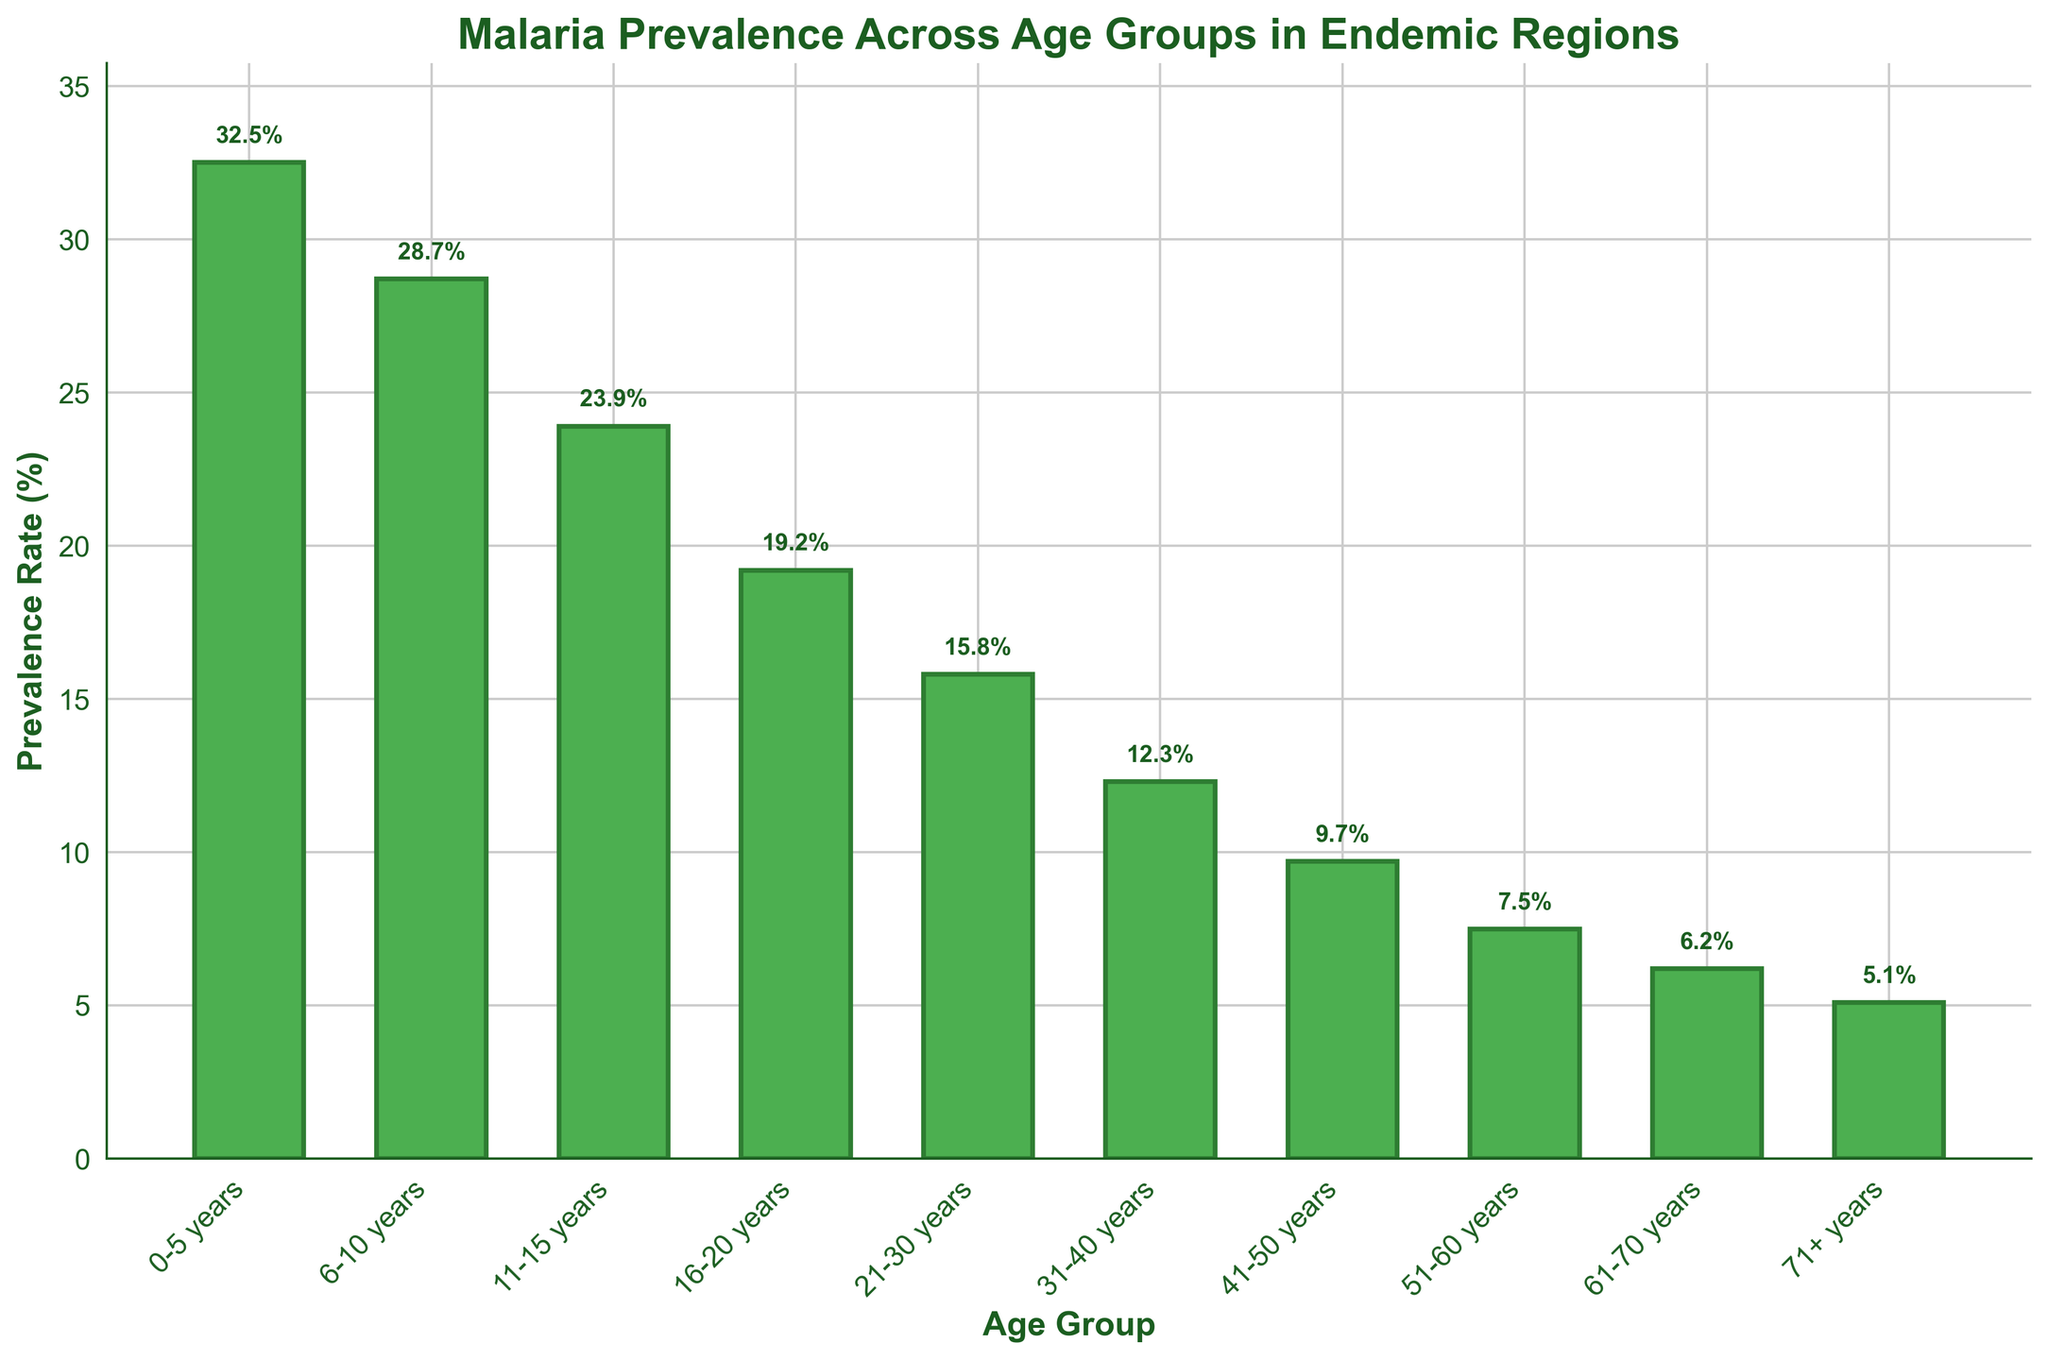What age group has the highest malaria prevalence rate? The figure shows the highest bar corresponding to the age group 0-5 years with a prevalence rate of 32.5%.
Answer: 0-5 years What age group has the lowest malaria prevalence rate? The figure shows the shortest bar corresponding to the age group 71+ years with a prevalence rate of 5.1%.
Answer: 71+ years What is the difference in malaria prevalence between the age groups 0-5 years and 51-60 years? The figure shows the prevalence for 0-5 years as 32.5% and for 51-60 years as 7.5%. Therefore, the difference is 32.5% - 7.5%.
Answer: 25% How does the prevalence rate change as age increases from 0-5 years to 71+ years? By observing the heights of the bars, it can be seen that the prevalence rate decreases as the age group increases from 0-5 years to 71+ years.
Answer: Decreases Which age group has a prevalence rate closest to 20%? The figure shows that the prevalence rate for the age group 16-20 years is 19.2%, which is closest to 20%.
Answer: 16-20 years What is the sum of the prevalence rates for the age groups 21-30 years and 31-40 years? The prevalence rates for the age groups 21-30 years and 31-40 years are 15.8% and 12.3%, respectively. Adding these values together gives 15.8% + 12.3%.
Answer: 28.1% Is the prevalence rate for the age group 41-50 years greater or less than 10%? The figure shows the prevalence rate for the age group 41-50 years as 9.7%, which is less than 10%.
Answer: Less What is the average prevalence rate of malaria for all age groups under 20 years? The prevalence rates for the age groups 0-5 years, 6-10 years, 11-15 years, and 16-20 years are 32.5%, 28.7%, 23.9%, and 19.2% respectively. The average is calculated as follows: (32.5 + 28.7 + 23.9 + 19.2) / 4.
Answer: 26.075% By how much does the prevalence rate drop from the age group 11-15 years to the age group 31-40 years? The prevalence rate for the age group 11-15 years is 23.9%, and for the age group 31-40 years is 12.3%. The drop is calculated as 23.9% - 12.3%.
Answer: 11.6% What is the median prevalence rate among all the age groups? To find the median, first arrange the prevalence rates in order: 5.1%, 6.2%, 7.5%, 9.7%, 12.3%, 15.8%, 19.2%, 23.9%, 28.7%, 32.5%. The median is the average of the 5th and 6th values: (12.3% + 15.8%) / 2.
Answer: 14.05% 